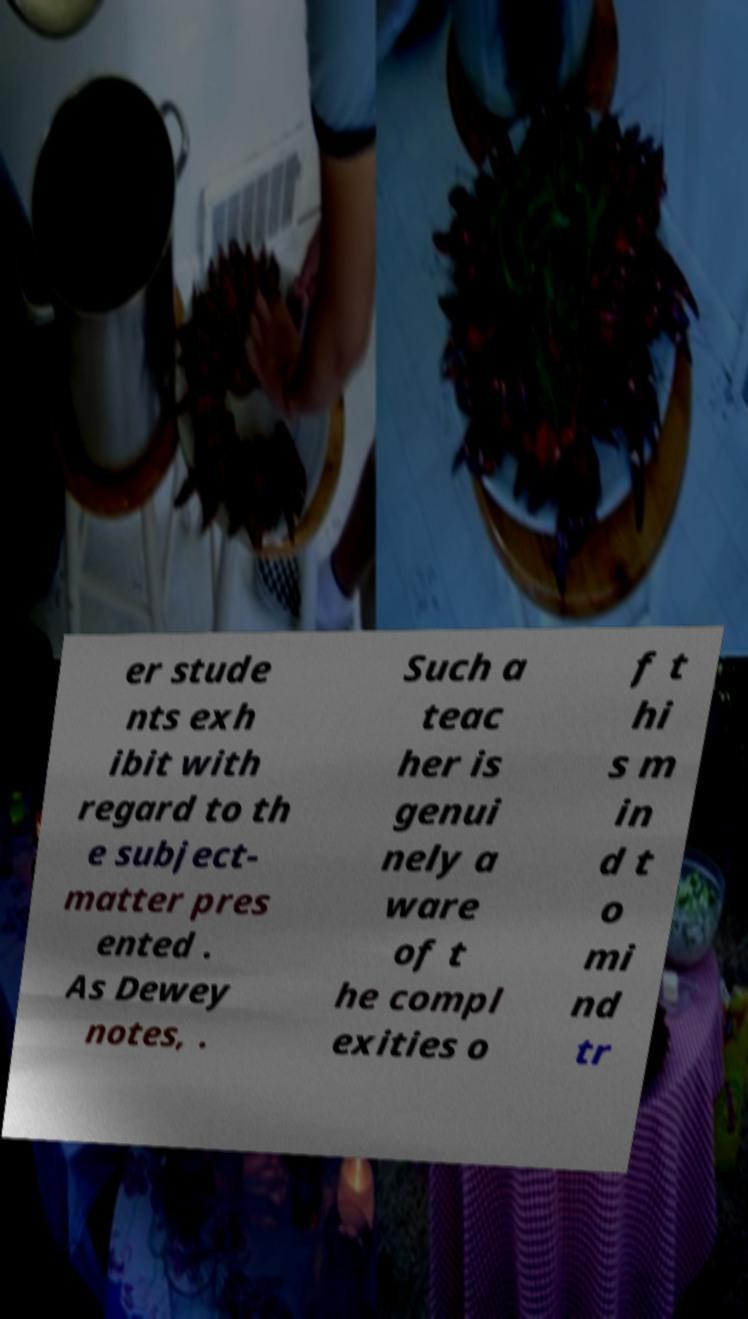Could you extract and type out the text from this image? er stude nts exh ibit with regard to th e subject- matter pres ented . As Dewey notes, . Such a teac her is genui nely a ware of t he compl exities o f t hi s m in d t o mi nd tr 